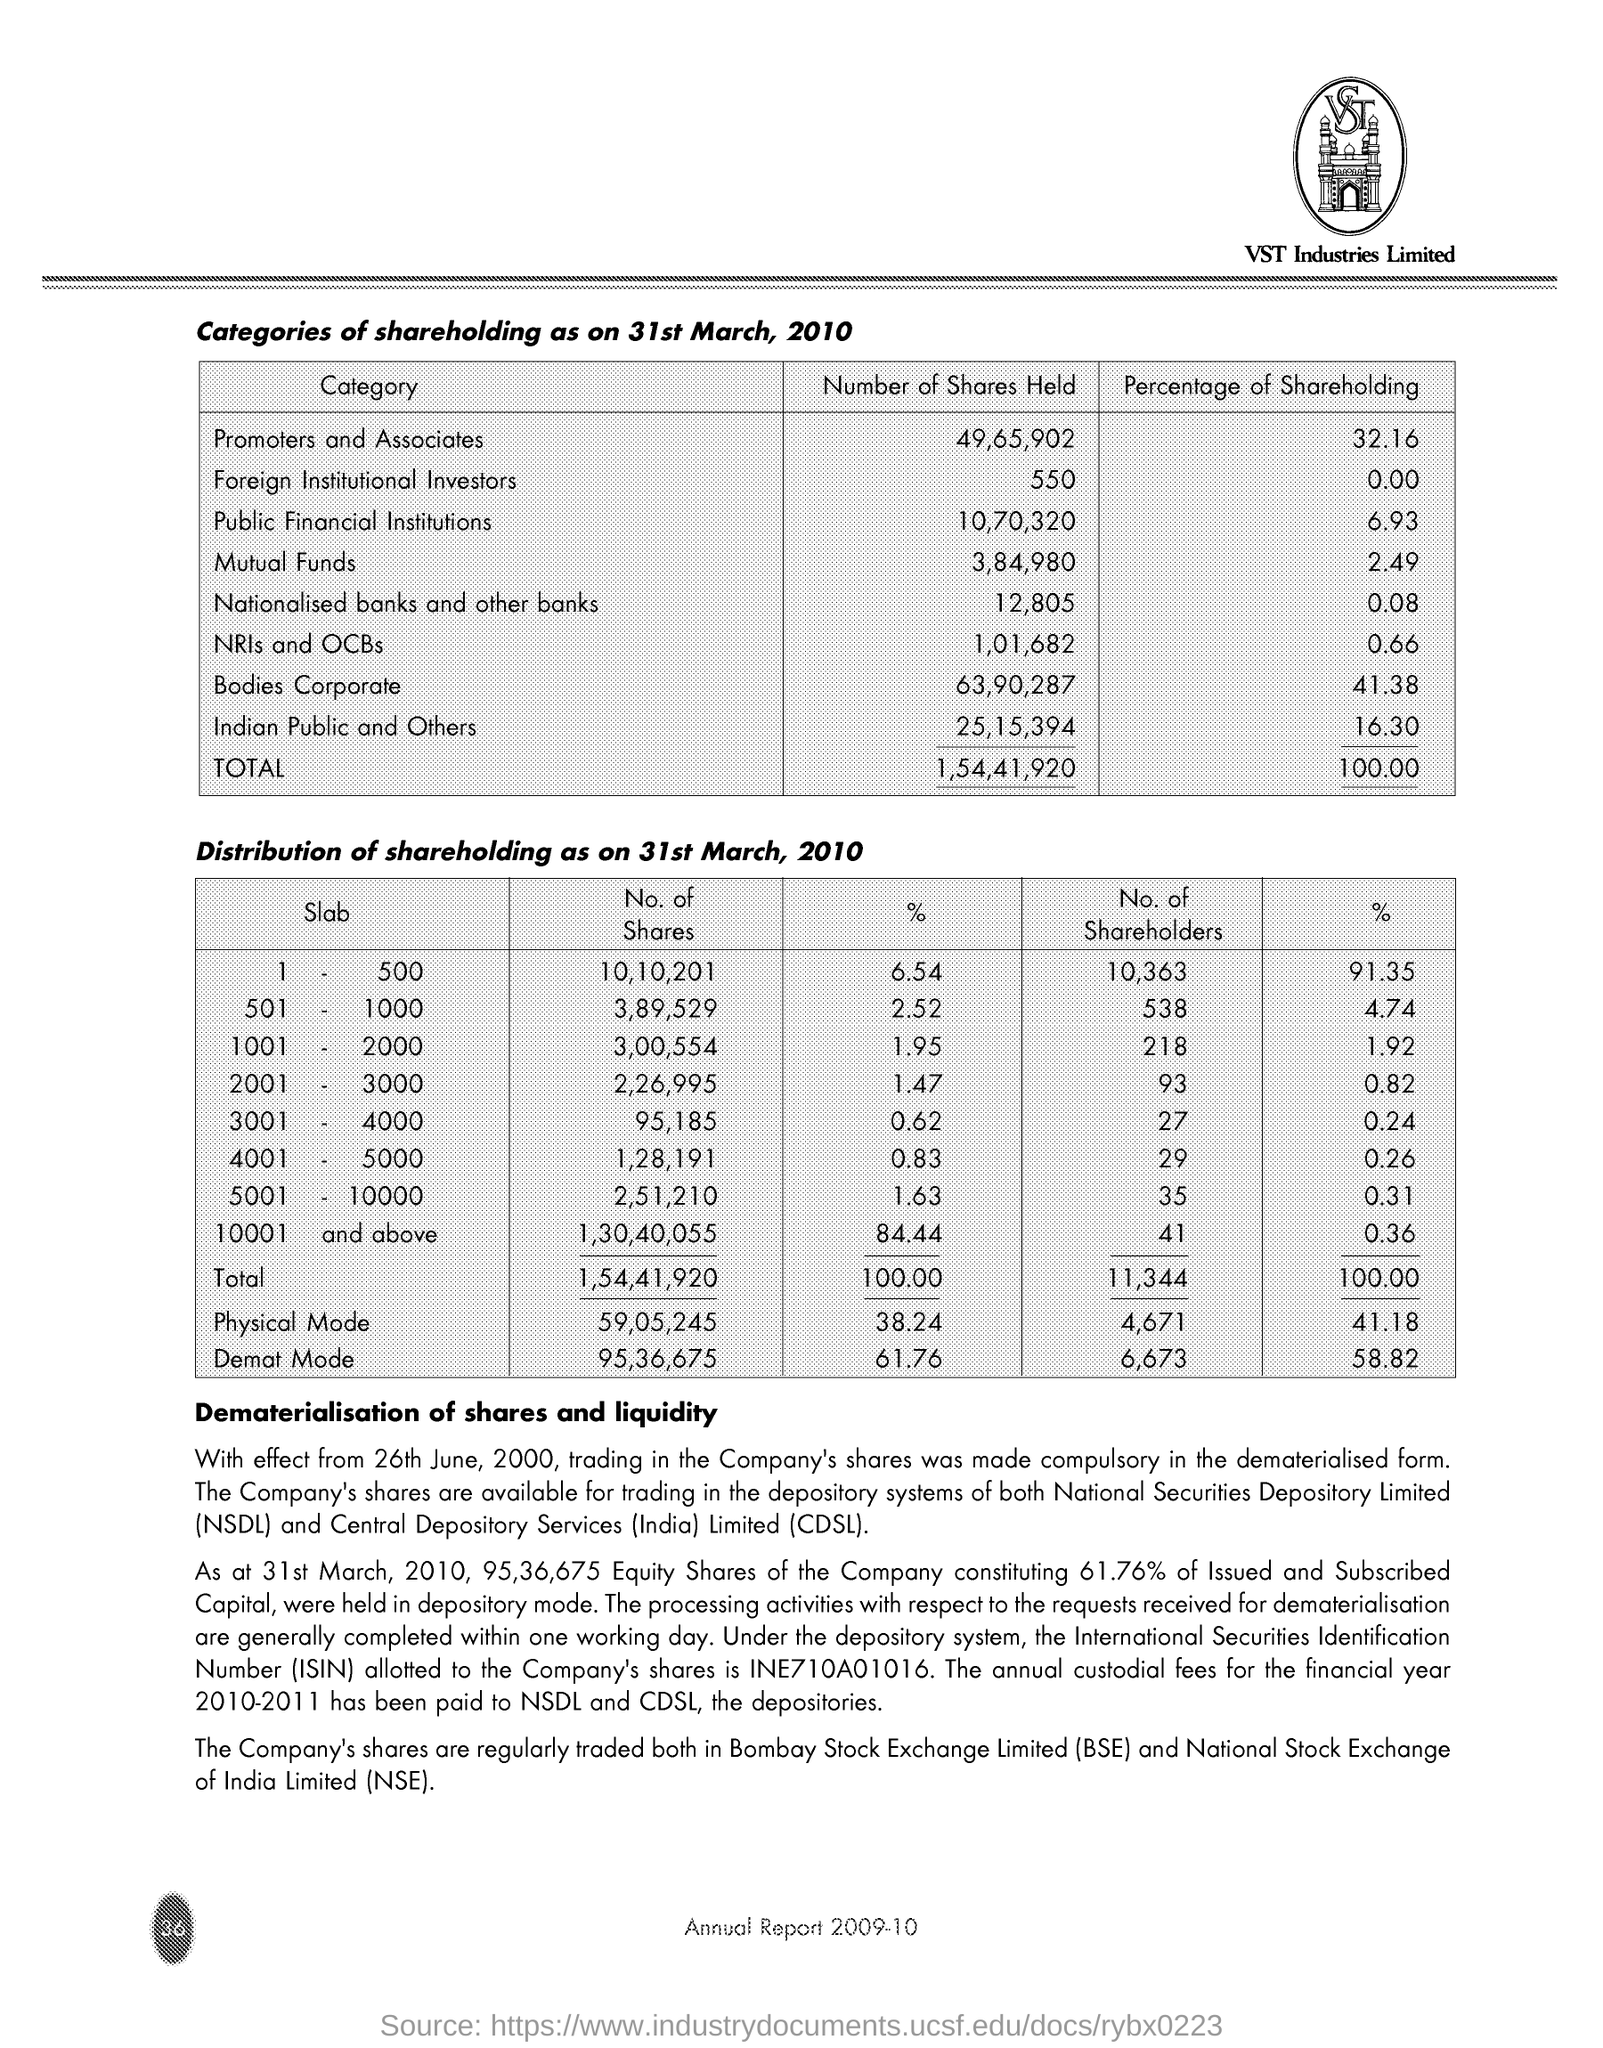Give some essential details in this illustration. The promotion group and associates hold a total of 49,65,902 shares. The mutual fund holds 2.49% of the company's shares. There are 3,84,980 shares held by mutual funds. The percentage of share holding by promoters and associates is 32.16%. 